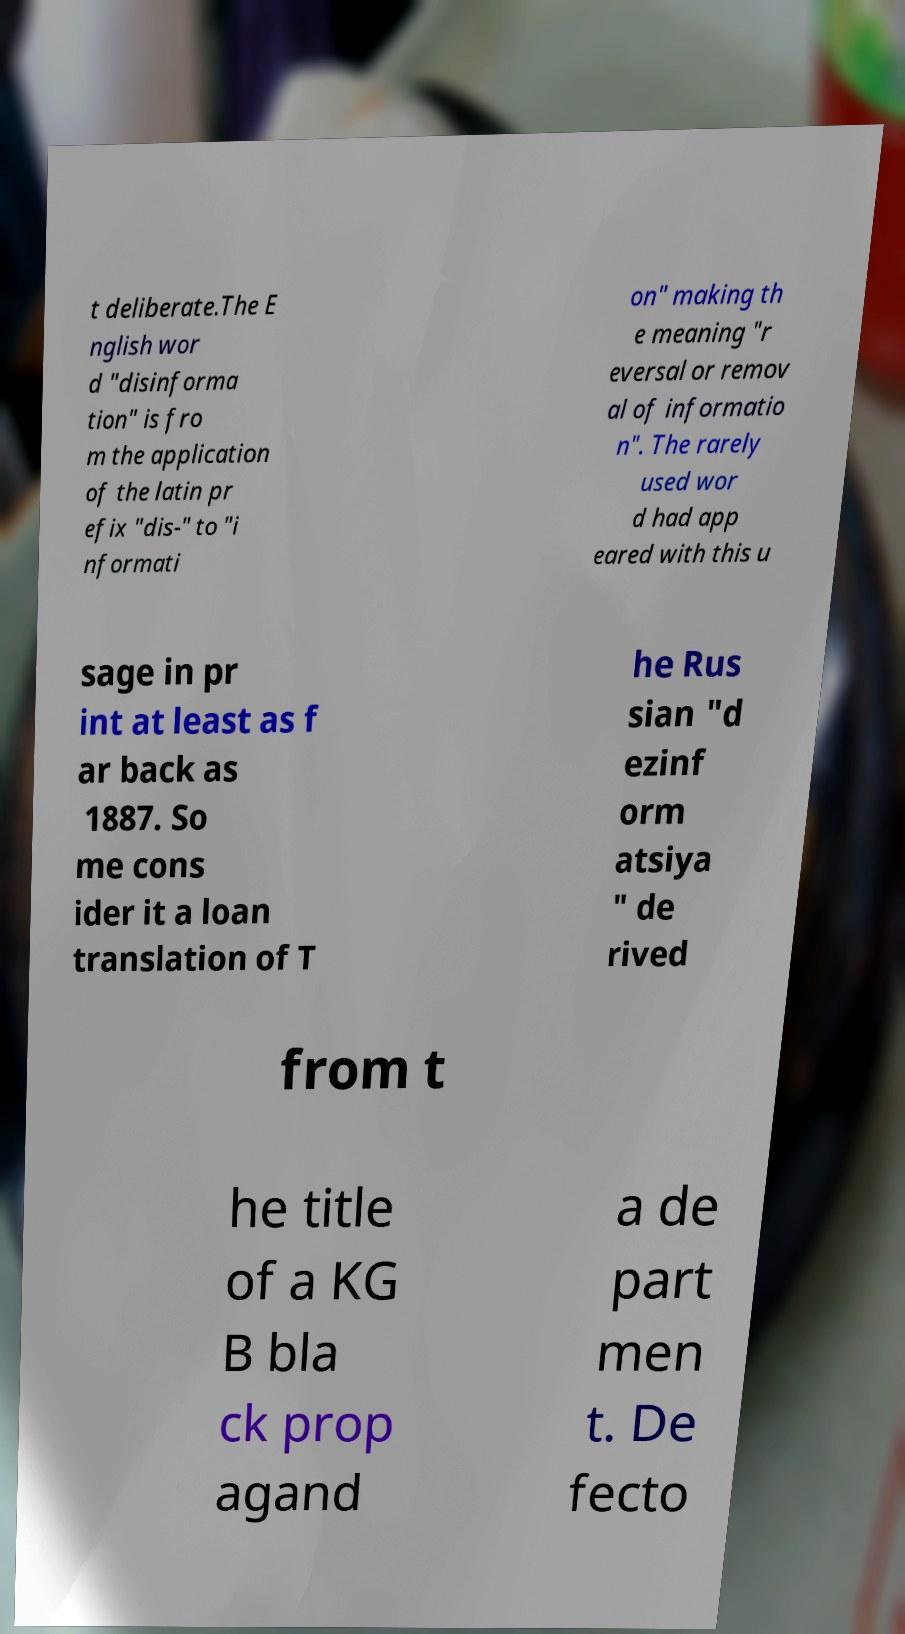Could you extract and type out the text from this image? t deliberate.The E nglish wor d "disinforma tion" is fro m the application of the latin pr efix "dis-" to "i nformati on" making th e meaning "r eversal or remov al of informatio n". The rarely used wor d had app eared with this u sage in pr int at least as f ar back as 1887. So me cons ider it a loan translation of T he Rus sian "d ezinf orm atsiya " de rived from t he title of a KG B bla ck prop agand a de part men t. De fecto 